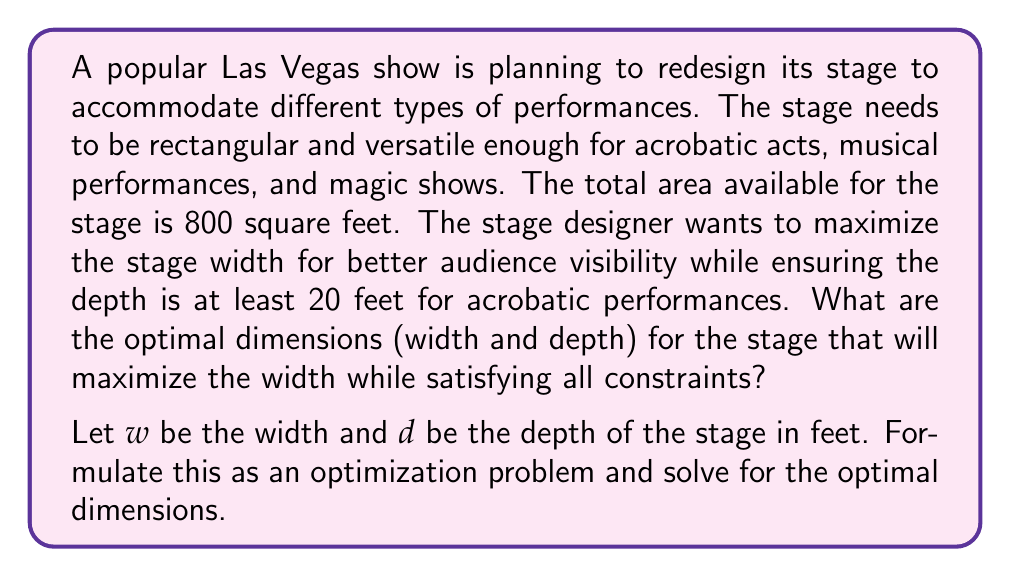Can you answer this question? To solve this problem, we'll follow these steps:

1) First, let's define our constraints:
   - The total area is 800 square feet: $w \cdot d = 800$
   - The depth must be at least 20 feet: $d \geq 20$
   - We want to maximize the width $w$

2) From the area constraint, we can express $w$ in terms of $d$:
   $w = \frac{800}{d}$

3) Our objective is to maximize $w$, which is equivalent to minimizing $d$ (since they're inversely related).

4) Given the constraint $d \geq 20$, the minimum value $d$ can take is 20.

5) Therefore, the optimal solution is:
   $d = 20$
   $w = \frac{800}{20} = 40$

6) We can verify that this satisfies our area constraint:
   $40 \cdot 20 = 800$ square feet

This solution maximizes the width while ensuring the depth is sufficient for acrobatic performances. The rectangular shape (40 feet wide by 20 feet deep) provides versatility for various types of shows.

For a visual representation:

[asy]
unitsize(5mm);
draw((0,0)--(40,0)--(40,20)--(0,20)--cycle);
label("40 ft", (20,0), S);
label("20 ft", (40,10), E);
label("Stage", (20,10));
[/asy]

This optimal design allows for a wide viewing angle for the audience while providing enough depth for complex performances, making it suitable for various Las Vegas shows including acrobatics, musical acts, and magic performances.
Answer: The optimal dimensions for the stage are:
Width: $w = 40$ feet
Depth: $d = 20$ feet 